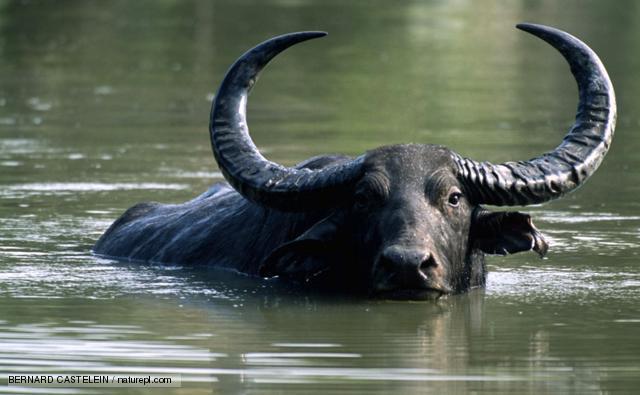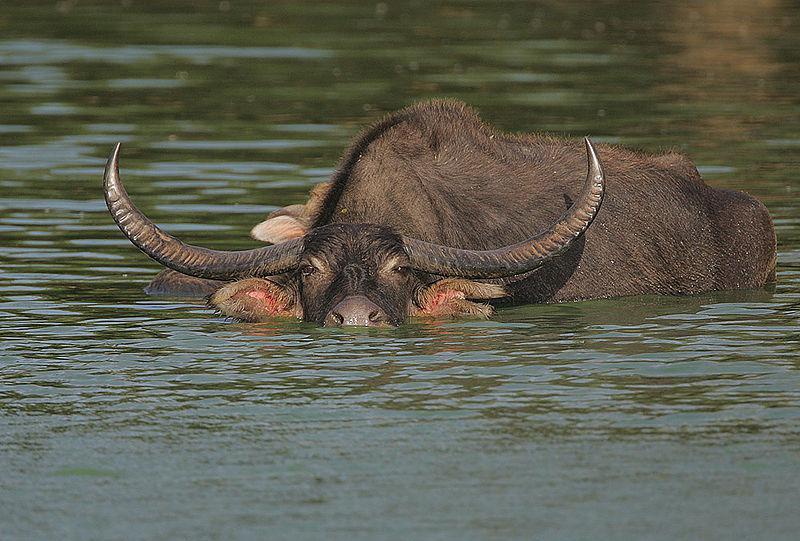The first image is the image on the left, the second image is the image on the right. Examine the images to the left and right. Is the description "At least one young boy is in the water near a water buffalo in one image." accurate? Answer yes or no. No. The first image is the image on the left, the second image is the image on the right. Analyze the images presented: Is the assertion "There is at least one human child in one of the images." valid? Answer yes or no. No. 